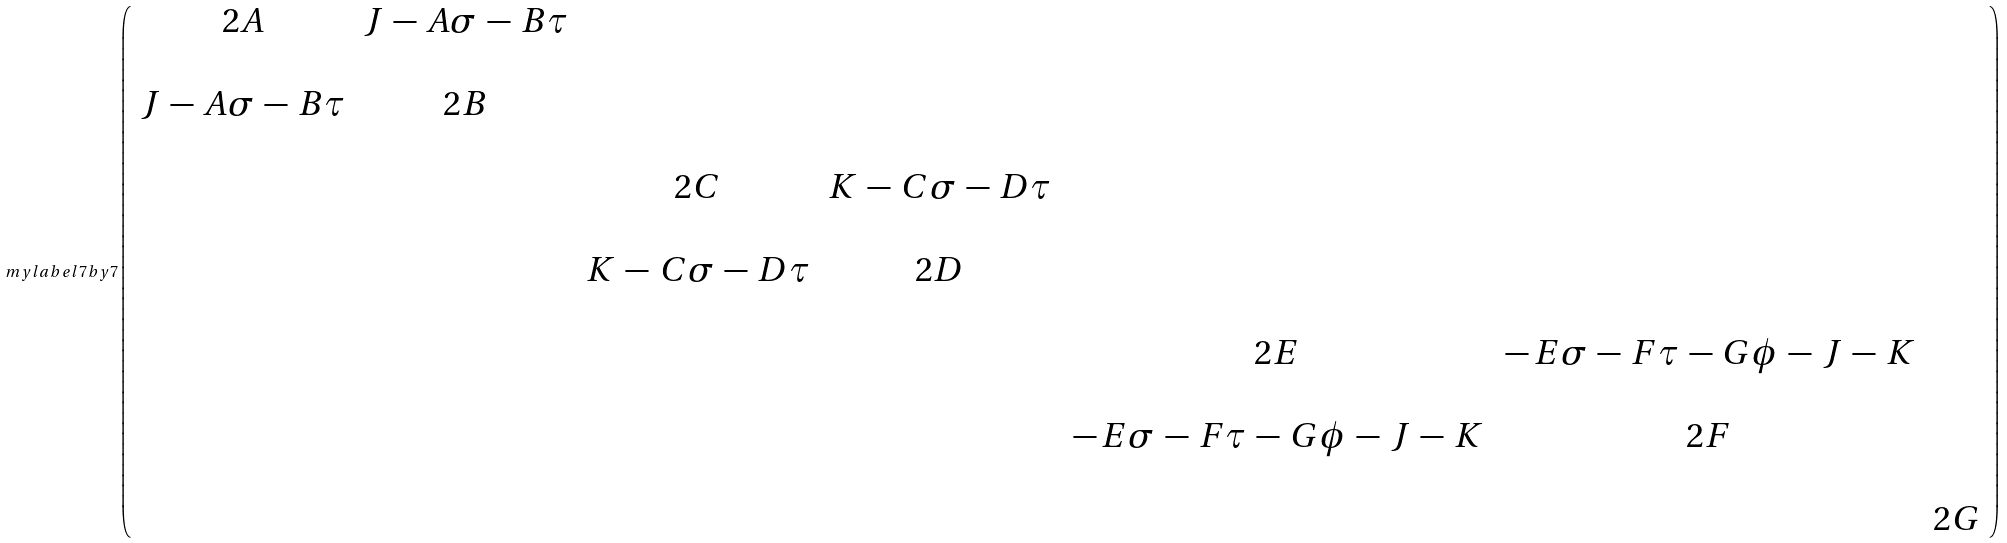<formula> <loc_0><loc_0><loc_500><loc_500>\ m y l a b e l { 7 b y 7 } \left ( \begin{array} { c c c c c c c } 2 A & J \, - \, A \sigma \, - \, B \tau & & & & & \\ \\ J \, - \, A \sigma \, - \, B \tau & 2 B & & & & & \\ \\ & & 2 C & K \, - \, C \sigma \, - \, D \tau & & & \\ \\ & & K \, - \, C \sigma \, - \, D \tau & 2 D & & & \\ \\ & & & & 2 E & \, - \, E \sigma \, - \, F \tau \, - \, G \phi \, - \, J \, - \, K & \\ \\ & & & & \, - \, E \sigma \, - \, F \tau \, - \, G \phi \, - \, J \, - \, K & 2 F & \\ \\ & & & & & & 2 G \end{array} \right )</formula> 